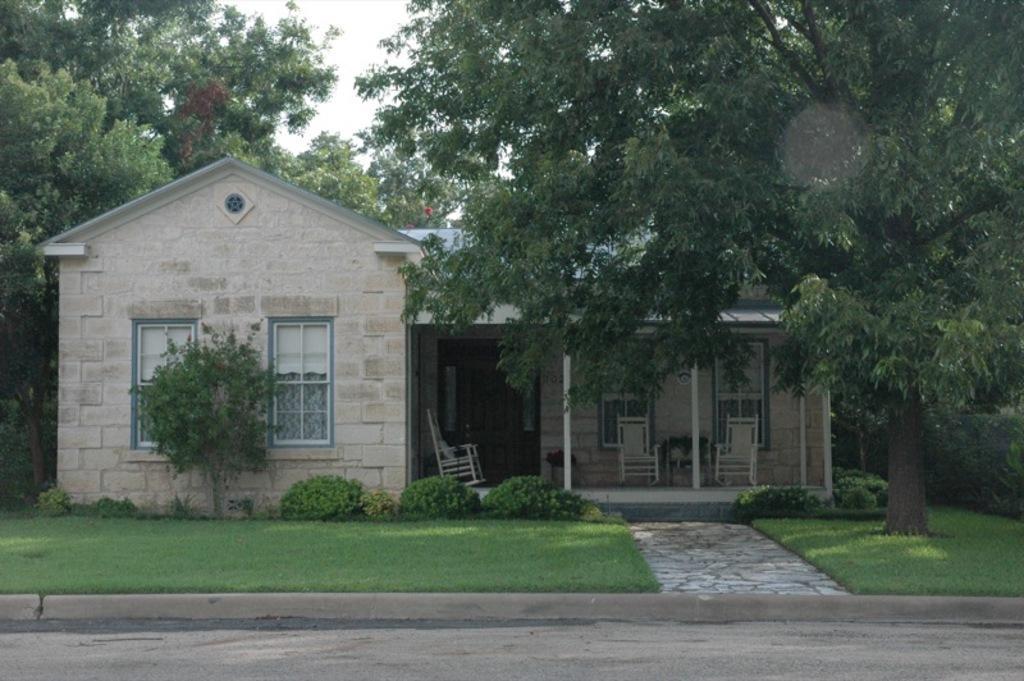Please provide a concise description of this image. In the center of the picture there are plants, house, chairs, windows and trees. In the foreground there are road and grass. 